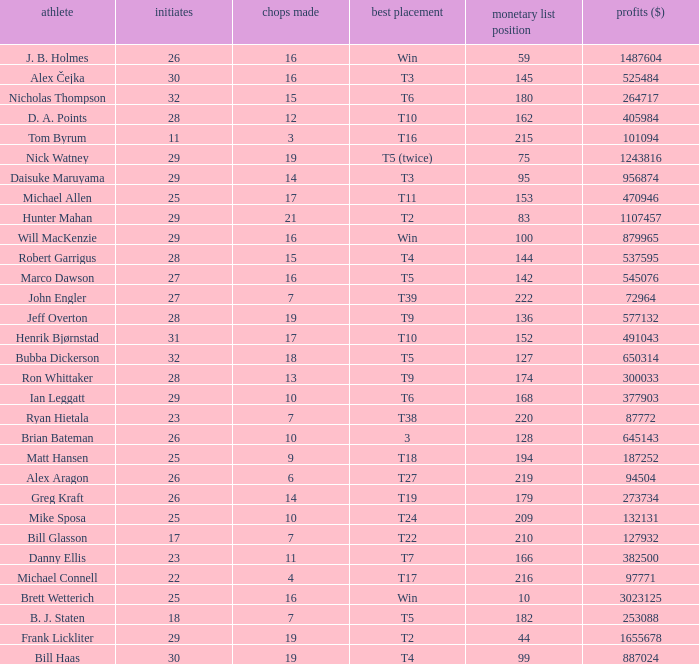What is the minimum money list rank for the players having a best finish of T9? 136.0. Help me parse the entirety of this table. {'header': ['athlete', 'initiates', 'chops made', 'best placement', 'monetary list position', 'profits ($)'], 'rows': [['J. B. Holmes', '26', '16', 'Win', '59', '1487604'], ['Alex Čejka', '30', '16', 'T3', '145', '525484'], ['Nicholas Thompson', '32', '15', 'T6', '180', '264717'], ['D. A. Points', '28', '12', 'T10', '162', '405984'], ['Tom Byrum', '11', '3', 'T16', '215', '101094'], ['Nick Watney', '29', '19', 'T5 (twice)', '75', '1243816'], ['Daisuke Maruyama', '29', '14', 'T3', '95', '956874'], ['Michael Allen', '25', '17', 'T11', '153', '470946'], ['Hunter Mahan', '29', '21', 'T2', '83', '1107457'], ['Will MacKenzie', '29', '16', 'Win', '100', '879965'], ['Robert Garrigus', '28', '15', 'T4', '144', '537595'], ['Marco Dawson', '27', '16', 'T5', '142', '545076'], ['John Engler', '27', '7', 'T39', '222', '72964'], ['Jeff Overton', '28', '19', 'T9', '136', '577132'], ['Henrik Bjørnstad', '31', '17', 'T10', '152', '491043'], ['Bubba Dickerson', '32', '18', 'T5', '127', '650314'], ['Ron Whittaker', '28', '13', 'T9', '174', '300033'], ['Ian Leggatt', '29', '10', 'T6', '168', '377903'], ['Ryan Hietala', '23', '7', 'T38', '220', '87772'], ['Brian Bateman', '26', '10', '3', '128', '645143'], ['Matt Hansen', '25', '9', 'T18', '194', '187252'], ['Alex Aragon', '26', '6', 'T27', '219', '94504'], ['Greg Kraft', '26', '14', 'T19', '179', '273734'], ['Mike Sposa', '25', '10', 'T24', '209', '132131'], ['Bill Glasson', '17', '7', 'T22', '210', '127932'], ['Danny Ellis', '23', '11', 'T7', '166', '382500'], ['Michael Connell', '22', '4', 'T17', '216', '97771'], ['Brett Wetterich', '25', '16', 'Win', '10', '3023125'], ['B. J. Staten', '18', '7', 'T5', '182', '253088'], ['Frank Lickliter', '29', '19', 'T2', '44', '1655678'], ['Bill Haas', '30', '19', 'T4', '99', '887024']]} 